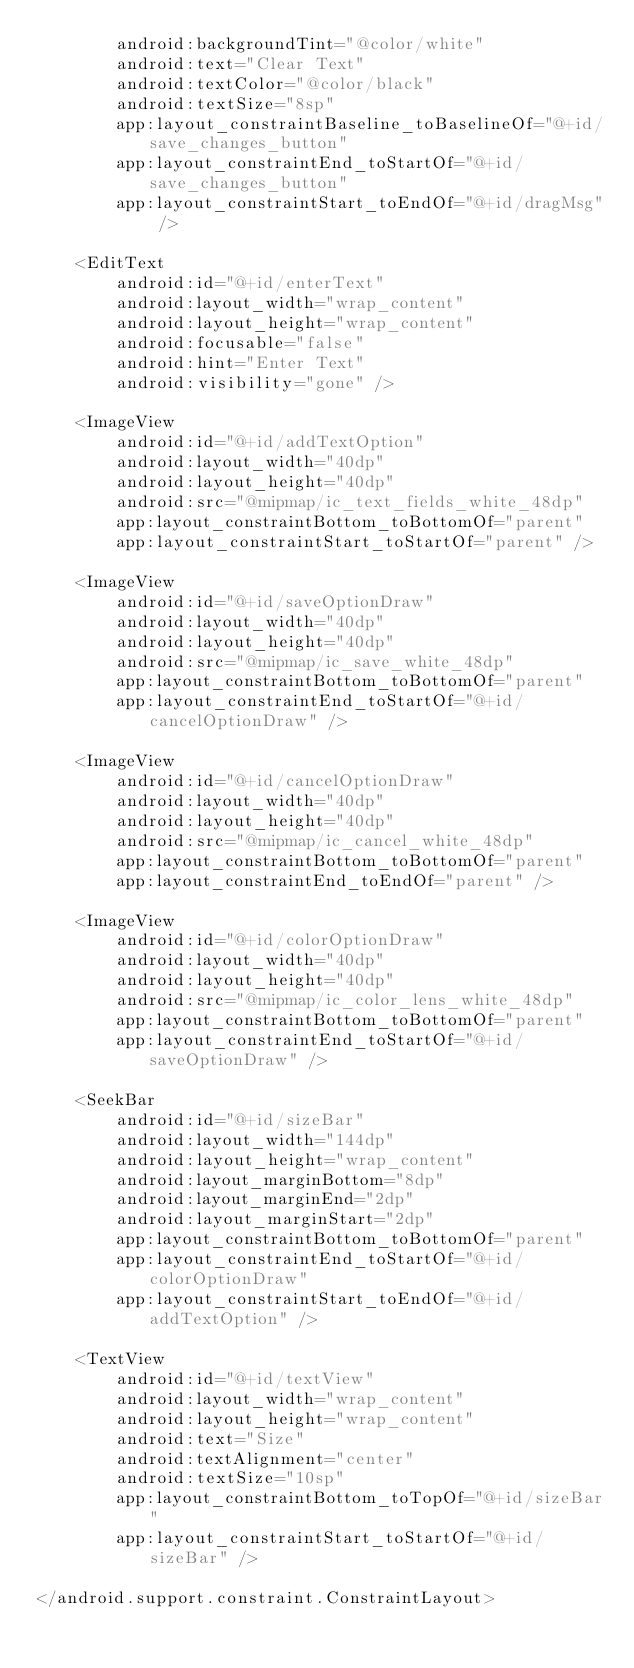Convert code to text. <code><loc_0><loc_0><loc_500><loc_500><_XML_>        android:backgroundTint="@color/white"
        android:text="Clear Text"
        android:textColor="@color/black"
        android:textSize="8sp"
        app:layout_constraintBaseline_toBaselineOf="@+id/save_changes_button"
        app:layout_constraintEnd_toStartOf="@+id/save_changes_button"
        app:layout_constraintStart_toEndOf="@+id/dragMsg" />

    <EditText
        android:id="@+id/enterText"
        android:layout_width="wrap_content"
        android:layout_height="wrap_content"
        android:focusable="false"
        android:hint="Enter Text"
        android:visibility="gone" />

    <ImageView
        android:id="@+id/addTextOption"
        android:layout_width="40dp"
        android:layout_height="40dp"
        android:src="@mipmap/ic_text_fields_white_48dp"
        app:layout_constraintBottom_toBottomOf="parent"
        app:layout_constraintStart_toStartOf="parent" />

    <ImageView
        android:id="@+id/saveOptionDraw"
        android:layout_width="40dp"
        android:layout_height="40dp"
        android:src="@mipmap/ic_save_white_48dp"
        app:layout_constraintBottom_toBottomOf="parent"
        app:layout_constraintEnd_toStartOf="@+id/cancelOptionDraw" />

    <ImageView
        android:id="@+id/cancelOptionDraw"
        android:layout_width="40dp"
        android:layout_height="40dp"
        android:src="@mipmap/ic_cancel_white_48dp"
        app:layout_constraintBottom_toBottomOf="parent"
        app:layout_constraintEnd_toEndOf="parent" />

    <ImageView
        android:id="@+id/colorOptionDraw"
        android:layout_width="40dp"
        android:layout_height="40dp"
        android:src="@mipmap/ic_color_lens_white_48dp"
        app:layout_constraintBottom_toBottomOf="parent"
        app:layout_constraintEnd_toStartOf="@+id/saveOptionDraw" />

    <SeekBar
        android:id="@+id/sizeBar"
        android:layout_width="144dp"
        android:layout_height="wrap_content"
        android:layout_marginBottom="8dp"
        android:layout_marginEnd="2dp"
        android:layout_marginStart="2dp"
        app:layout_constraintBottom_toBottomOf="parent"
        app:layout_constraintEnd_toStartOf="@+id/colorOptionDraw"
        app:layout_constraintStart_toEndOf="@+id/addTextOption" />

    <TextView
        android:id="@+id/textView"
        android:layout_width="wrap_content"
        android:layout_height="wrap_content"
        android:text="Size"
        android:textAlignment="center"
        android:textSize="10sp"
        app:layout_constraintBottom_toTopOf="@+id/sizeBar"
        app:layout_constraintStart_toStartOf="@+id/sizeBar" />

</android.support.constraint.ConstraintLayout>
</code> 